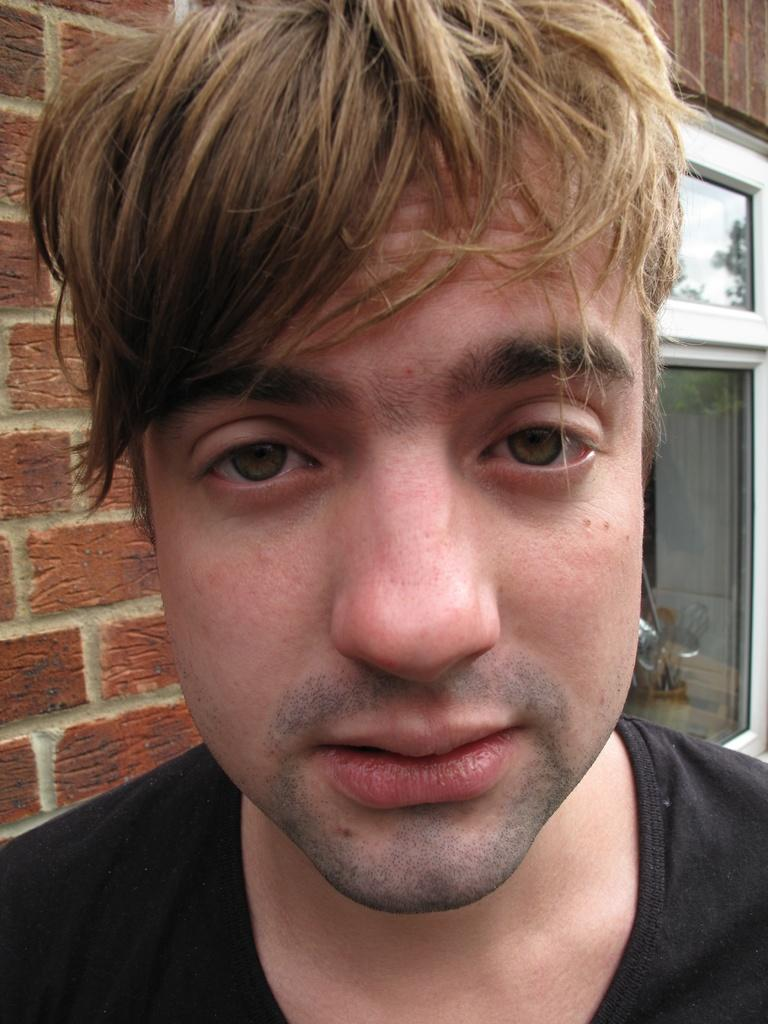Who is present in the image? There is a man in the image. What can be seen behind the man? There is a wall visible in the image. Is there any opening in the wall visible in the image? Yes, there is a window visible in the image. What type of glove is the man wearing in the image? There is no glove visible in the image. 